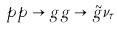<formula> <loc_0><loc_0><loc_500><loc_500>p p \rightarrow g g \rightarrow \tilde { g } \nu _ { \tau }</formula> 